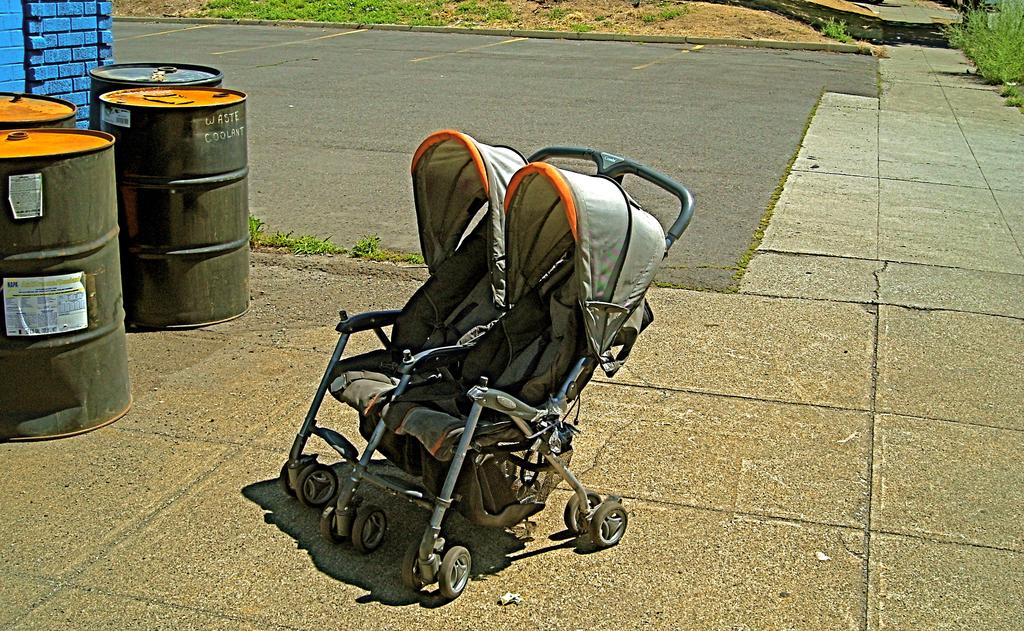What is the main object in the image? There is a baby stroller in the image. What other objects can be seen in the image? There are drums, a wall, plants on the pavement, a road beside the pavement, and sand beside the road in the image. How many stars can be seen in the image? There are no stars visible in the image. Are there any boys playing with the drums in the image? There is no mention of boys or any people playing with the drums in the image. 